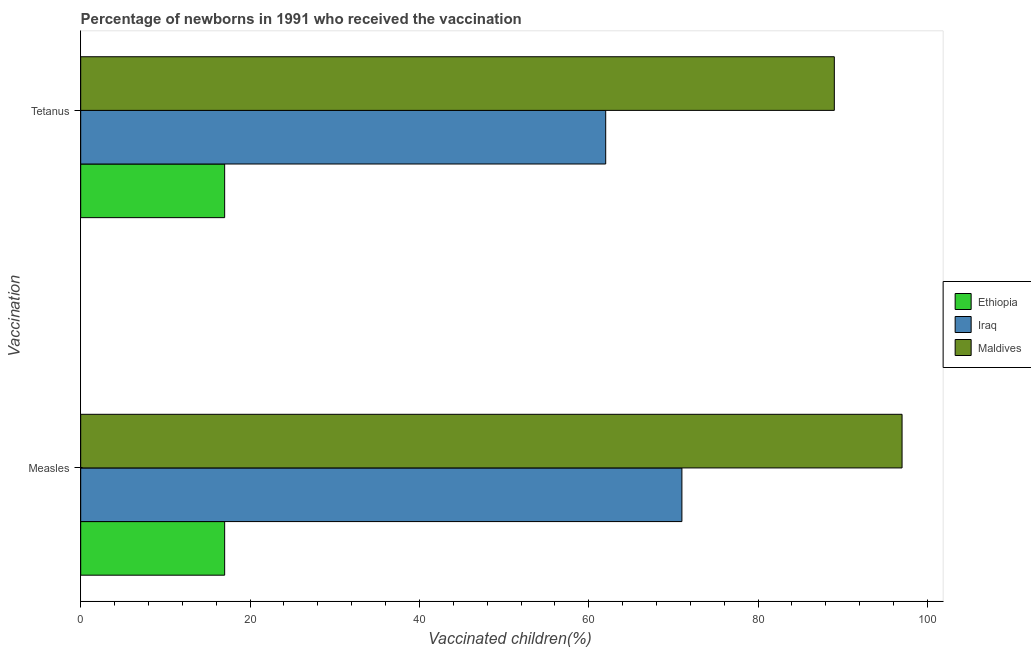How many different coloured bars are there?
Your answer should be very brief. 3. Are the number of bars per tick equal to the number of legend labels?
Your response must be concise. Yes. How many bars are there on the 1st tick from the top?
Provide a succinct answer. 3. What is the label of the 2nd group of bars from the top?
Ensure brevity in your answer.  Measles. What is the percentage of newborns who received vaccination for tetanus in Iraq?
Provide a succinct answer. 62. Across all countries, what is the maximum percentage of newborns who received vaccination for tetanus?
Your response must be concise. 89. Across all countries, what is the minimum percentage of newborns who received vaccination for tetanus?
Provide a short and direct response. 17. In which country was the percentage of newborns who received vaccination for tetanus maximum?
Provide a succinct answer. Maldives. In which country was the percentage of newborns who received vaccination for tetanus minimum?
Your answer should be very brief. Ethiopia. What is the total percentage of newborns who received vaccination for tetanus in the graph?
Your answer should be very brief. 168. What is the difference between the percentage of newborns who received vaccination for measles in Maldives and that in Iraq?
Provide a succinct answer. 26. What is the difference between the percentage of newborns who received vaccination for measles in Maldives and the percentage of newborns who received vaccination for tetanus in Iraq?
Your response must be concise. 35. What is the average percentage of newborns who received vaccination for measles per country?
Keep it short and to the point. 61.67. What is the difference between the percentage of newborns who received vaccination for tetanus and percentage of newborns who received vaccination for measles in Iraq?
Keep it short and to the point. -9. What is the ratio of the percentage of newborns who received vaccination for measles in Ethiopia to that in Iraq?
Make the answer very short. 0.24. What does the 3rd bar from the top in Tetanus represents?
Offer a terse response. Ethiopia. What does the 2nd bar from the bottom in Measles represents?
Provide a succinct answer. Iraq. How many bars are there?
Your response must be concise. 6. Are all the bars in the graph horizontal?
Your answer should be very brief. Yes. What is the difference between two consecutive major ticks on the X-axis?
Offer a terse response. 20. Does the graph contain grids?
Provide a succinct answer. No. How are the legend labels stacked?
Give a very brief answer. Vertical. What is the title of the graph?
Give a very brief answer. Percentage of newborns in 1991 who received the vaccination. Does "Tonga" appear as one of the legend labels in the graph?
Your answer should be very brief. No. What is the label or title of the X-axis?
Provide a succinct answer. Vaccinated children(%)
. What is the label or title of the Y-axis?
Provide a succinct answer. Vaccination. What is the Vaccinated children(%)
 of Maldives in Measles?
Your answer should be compact. 97. What is the Vaccinated children(%)
 in Ethiopia in Tetanus?
Keep it short and to the point. 17. What is the Vaccinated children(%)
 in Iraq in Tetanus?
Provide a short and direct response. 62. What is the Vaccinated children(%)
 of Maldives in Tetanus?
Give a very brief answer. 89. Across all Vaccination, what is the maximum Vaccinated children(%)
 in Ethiopia?
Your answer should be compact. 17. Across all Vaccination, what is the maximum Vaccinated children(%)
 in Maldives?
Make the answer very short. 97. Across all Vaccination, what is the minimum Vaccinated children(%)
 of Maldives?
Offer a terse response. 89. What is the total Vaccinated children(%)
 in Ethiopia in the graph?
Your answer should be very brief. 34. What is the total Vaccinated children(%)
 in Iraq in the graph?
Give a very brief answer. 133. What is the total Vaccinated children(%)
 in Maldives in the graph?
Your answer should be compact. 186. What is the difference between the Vaccinated children(%)
 of Ethiopia in Measles and the Vaccinated children(%)
 of Iraq in Tetanus?
Keep it short and to the point. -45. What is the difference between the Vaccinated children(%)
 of Ethiopia in Measles and the Vaccinated children(%)
 of Maldives in Tetanus?
Offer a terse response. -72. What is the average Vaccinated children(%)
 in Ethiopia per Vaccination?
Offer a terse response. 17. What is the average Vaccinated children(%)
 of Iraq per Vaccination?
Offer a terse response. 66.5. What is the average Vaccinated children(%)
 in Maldives per Vaccination?
Provide a short and direct response. 93. What is the difference between the Vaccinated children(%)
 in Ethiopia and Vaccinated children(%)
 in Iraq in Measles?
Make the answer very short. -54. What is the difference between the Vaccinated children(%)
 of Ethiopia and Vaccinated children(%)
 of Maldives in Measles?
Your answer should be compact. -80. What is the difference between the Vaccinated children(%)
 of Ethiopia and Vaccinated children(%)
 of Iraq in Tetanus?
Keep it short and to the point. -45. What is the difference between the Vaccinated children(%)
 of Ethiopia and Vaccinated children(%)
 of Maldives in Tetanus?
Your answer should be very brief. -72. What is the ratio of the Vaccinated children(%)
 of Ethiopia in Measles to that in Tetanus?
Keep it short and to the point. 1. What is the ratio of the Vaccinated children(%)
 of Iraq in Measles to that in Tetanus?
Ensure brevity in your answer.  1.15. What is the ratio of the Vaccinated children(%)
 of Maldives in Measles to that in Tetanus?
Your answer should be compact. 1.09. What is the difference between the highest and the second highest Vaccinated children(%)
 of Ethiopia?
Offer a terse response. 0. What is the difference between the highest and the second highest Vaccinated children(%)
 of Maldives?
Make the answer very short. 8. 